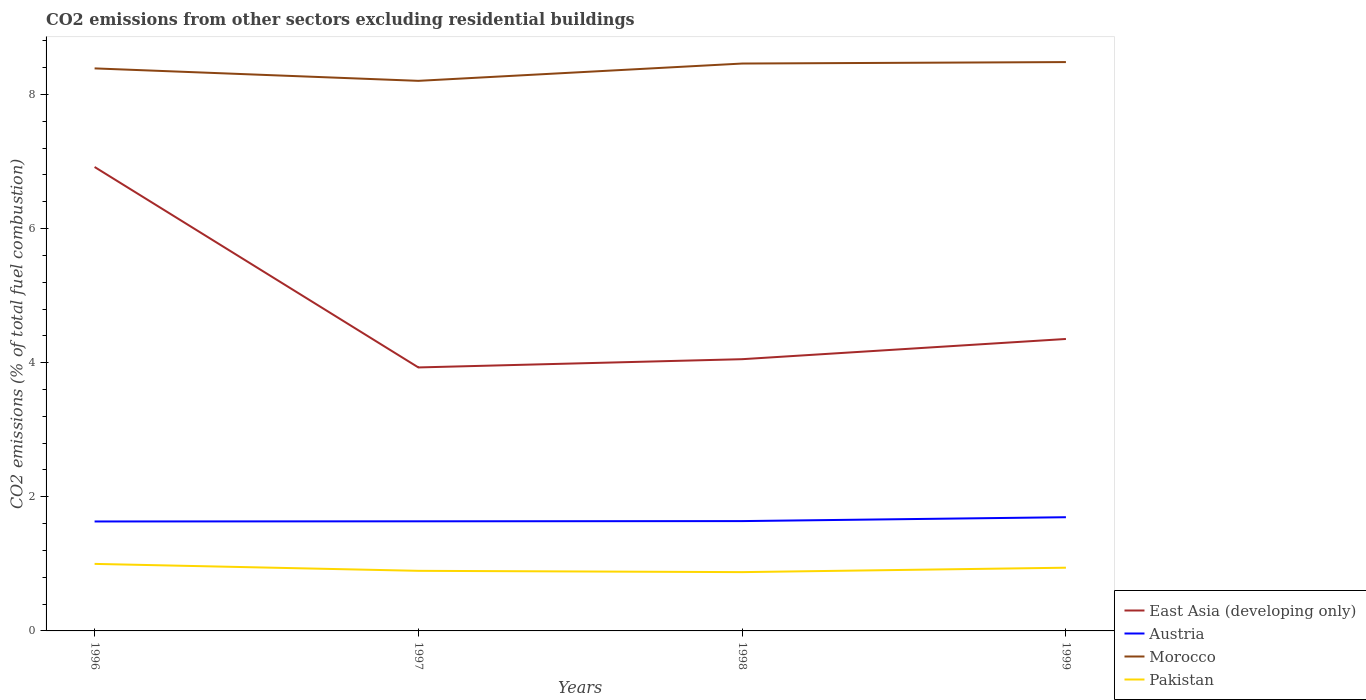How many different coloured lines are there?
Provide a short and direct response. 4. Does the line corresponding to Morocco intersect with the line corresponding to Austria?
Give a very brief answer. No. Is the number of lines equal to the number of legend labels?
Make the answer very short. Yes. Across all years, what is the maximum total CO2 emitted in Pakistan?
Provide a short and direct response. 0.88. What is the total total CO2 emitted in Pakistan in the graph?
Ensure brevity in your answer.  0.1. What is the difference between the highest and the second highest total CO2 emitted in East Asia (developing only)?
Provide a succinct answer. 2.99. What is the difference between the highest and the lowest total CO2 emitted in East Asia (developing only)?
Your response must be concise. 1. Is the total CO2 emitted in Morocco strictly greater than the total CO2 emitted in Pakistan over the years?
Keep it short and to the point. No. How many years are there in the graph?
Give a very brief answer. 4. Does the graph contain any zero values?
Your answer should be compact. No. Where does the legend appear in the graph?
Your answer should be compact. Bottom right. How are the legend labels stacked?
Give a very brief answer. Vertical. What is the title of the graph?
Keep it short and to the point. CO2 emissions from other sectors excluding residential buildings. What is the label or title of the X-axis?
Ensure brevity in your answer.  Years. What is the label or title of the Y-axis?
Provide a succinct answer. CO2 emissions (% of total fuel combustion). What is the CO2 emissions (% of total fuel combustion) of East Asia (developing only) in 1996?
Provide a succinct answer. 6.92. What is the CO2 emissions (% of total fuel combustion) of Austria in 1996?
Provide a short and direct response. 1.63. What is the CO2 emissions (% of total fuel combustion) in Morocco in 1996?
Offer a very short reply. 8.39. What is the CO2 emissions (% of total fuel combustion) of Pakistan in 1996?
Ensure brevity in your answer.  1. What is the CO2 emissions (% of total fuel combustion) in East Asia (developing only) in 1997?
Keep it short and to the point. 3.93. What is the CO2 emissions (% of total fuel combustion) in Austria in 1997?
Ensure brevity in your answer.  1.63. What is the CO2 emissions (% of total fuel combustion) in Morocco in 1997?
Make the answer very short. 8.2. What is the CO2 emissions (% of total fuel combustion) in Pakistan in 1997?
Offer a terse response. 0.9. What is the CO2 emissions (% of total fuel combustion) in East Asia (developing only) in 1998?
Give a very brief answer. 4.05. What is the CO2 emissions (% of total fuel combustion) in Austria in 1998?
Your answer should be very brief. 1.64. What is the CO2 emissions (% of total fuel combustion) of Morocco in 1998?
Provide a short and direct response. 8.46. What is the CO2 emissions (% of total fuel combustion) in Pakistan in 1998?
Your response must be concise. 0.88. What is the CO2 emissions (% of total fuel combustion) of East Asia (developing only) in 1999?
Offer a terse response. 4.35. What is the CO2 emissions (% of total fuel combustion) of Austria in 1999?
Provide a short and direct response. 1.7. What is the CO2 emissions (% of total fuel combustion) of Morocco in 1999?
Your answer should be very brief. 8.48. What is the CO2 emissions (% of total fuel combustion) in Pakistan in 1999?
Your answer should be compact. 0.94. Across all years, what is the maximum CO2 emissions (% of total fuel combustion) of East Asia (developing only)?
Your answer should be compact. 6.92. Across all years, what is the maximum CO2 emissions (% of total fuel combustion) of Austria?
Provide a succinct answer. 1.7. Across all years, what is the maximum CO2 emissions (% of total fuel combustion) in Morocco?
Keep it short and to the point. 8.48. Across all years, what is the maximum CO2 emissions (% of total fuel combustion) in Pakistan?
Ensure brevity in your answer.  1. Across all years, what is the minimum CO2 emissions (% of total fuel combustion) in East Asia (developing only)?
Keep it short and to the point. 3.93. Across all years, what is the minimum CO2 emissions (% of total fuel combustion) in Austria?
Offer a very short reply. 1.63. Across all years, what is the minimum CO2 emissions (% of total fuel combustion) in Morocco?
Offer a very short reply. 8.2. Across all years, what is the minimum CO2 emissions (% of total fuel combustion) in Pakistan?
Your response must be concise. 0.88. What is the total CO2 emissions (% of total fuel combustion) of East Asia (developing only) in the graph?
Make the answer very short. 19.25. What is the total CO2 emissions (% of total fuel combustion) of Austria in the graph?
Offer a terse response. 6.6. What is the total CO2 emissions (% of total fuel combustion) of Morocco in the graph?
Keep it short and to the point. 33.54. What is the total CO2 emissions (% of total fuel combustion) of Pakistan in the graph?
Offer a terse response. 3.71. What is the difference between the CO2 emissions (% of total fuel combustion) in East Asia (developing only) in 1996 and that in 1997?
Offer a terse response. 2.99. What is the difference between the CO2 emissions (% of total fuel combustion) of Austria in 1996 and that in 1997?
Offer a very short reply. -0. What is the difference between the CO2 emissions (% of total fuel combustion) in Morocco in 1996 and that in 1997?
Keep it short and to the point. 0.19. What is the difference between the CO2 emissions (% of total fuel combustion) in Pakistan in 1996 and that in 1997?
Make the answer very short. 0.1. What is the difference between the CO2 emissions (% of total fuel combustion) in East Asia (developing only) in 1996 and that in 1998?
Offer a terse response. 2.87. What is the difference between the CO2 emissions (% of total fuel combustion) of Austria in 1996 and that in 1998?
Provide a succinct answer. -0.01. What is the difference between the CO2 emissions (% of total fuel combustion) of Morocco in 1996 and that in 1998?
Offer a terse response. -0.07. What is the difference between the CO2 emissions (% of total fuel combustion) of Pakistan in 1996 and that in 1998?
Offer a very short reply. 0.12. What is the difference between the CO2 emissions (% of total fuel combustion) of East Asia (developing only) in 1996 and that in 1999?
Your answer should be compact. 2.56. What is the difference between the CO2 emissions (% of total fuel combustion) in Austria in 1996 and that in 1999?
Your response must be concise. -0.06. What is the difference between the CO2 emissions (% of total fuel combustion) in Morocco in 1996 and that in 1999?
Ensure brevity in your answer.  -0.09. What is the difference between the CO2 emissions (% of total fuel combustion) in Pakistan in 1996 and that in 1999?
Make the answer very short. 0.06. What is the difference between the CO2 emissions (% of total fuel combustion) of East Asia (developing only) in 1997 and that in 1998?
Make the answer very short. -0.12. What is the difference between the CO2 emissions (% of total fuel combustion) in Austria in 1997 and that in 1998?
Your response must be concise. -0. What is the difference between the CO2 emissions (% of total fuel combustion) in Morocco in 1997 and that in 1998?
Offer a very short reply. -0.26. What is the difference between the CO2 emissions (% of total fuel combustion) in Pakistan in 1997 and that in 1998?
Your answer should be compact. 0.02. What is the difference between the CO2 emissions (% of total fuel combustion) of East Asia (developing only) in 1997 and that in 1999?
Ensure brevity in your answer.  -0.42. What is the difference between the CO2 emissions (% of total fuel combustion) in Austria in 1997 and that in 1999?
Your answer should be compact. -0.06. What is the difference between the CO2 emissions (% of total fuel combustion) in Morocco in 1997 and that in 1999?
Make the answer very short. -0.28. What is the difference between the CO2 emissions (% of total fuel combustion) of Pakistan in 1997 and that in 1999?
Provide a short and direct response. -0.05. What is the difference between the CO2 emissions (% of total fuel combustion) of East Asia (developing only) in 1998 and that in 1999?
Provide a short and direct response. -0.3. What is the difference between the CO2 emissions (% of total fuel combustion) in Austria in 1998 and that in 1999?
Your answer should be compact. -0.06. What is the difference between the CO2 emissions (% of total fuel combustion) in Morocco in 1998 and that in 1999?
Provide a succinct answer. -0.02. What is the difference between the CO2 emissions (% of total fuel combustion) of Pakistan in 1998 and that in 1999?
Make the answer very short. -0.07. What is the difference between the CO2 emissions (% of total fuel combustion) in East Asia (developing only) in 1996 and the CO2 emissions (% of total fuel combustion) in Austria in 1997?
Your answer should be compact. 5.28. What is the difference between the CO2 emissions (% of total fuel combustion) of East Asia (developing only) in 1996 and the CO2 emissions (% of total fuel combustion) of Morocco in 1997?
Your answer should be very brief. -1.28. What is the difference between the CO2 emissions (% of total fuel combustion) of East Asia (developing only) in 1996 and the CO2 emissions (% of total fuel combustion) of Pakistan in 1997?
Your response must be concise. 6.02. What is the difference between the CO2 emissions (% of total fuel combustion) of Austria in 1996 and the CO2 emissions (% of total fuel combustion) of Morocco in 1997?
Offer a terse response. -6.57. What is the difference between the CO2 emissions (% of total fuel combustion) in Austria in 1996 and the CO2 emissions (% of total fuel combustion) in Pakistan in 1997?
Your answer should be compact. 0.74. What is the difference between the CO2 emissions (% of total fuel combustion) of Morocco in 1996 and the CO2 emissions (% of total fuel combustion) of Pakistan in 1997?
Your answer should be compact. 7.49. What is the difference between the CO2 emissions (% of total fuel combustion) of East Asia (developing only) in 1996 and the CO2 emissions (% of total fuel combustion) of Austria in 1998?
Give a very brief answer. 5.28. What is the difference between the CO2 emissions (% of total fuel combustion) in East Asia (developing only) in 1996 and the CO2 emissions (% of total fuel combustion) in Morocco in 1998?
Ensure brevity in your answer.  -1.54. What is the difference between the CO2 emissions (% of total fuel combustion) in East Asia (developing only) in 1996 and the CO2 emissions (% of total fuel combustion) in Pakistan in 1998?
Give a very brief answer. 6.04. What is the difference between the CO2 emissions (% of total fuel combustion) of Austria in 1996 and the CO2 emissions (% of total fuel combustion) of Morocco in 1998?
Your answer should be very brief. -6.83. What is the difference between the CO2 emissions (% of total fuel combustion) in Austria in 1996 and the CO2 emissions (% of total fuel combustion) in Pakistan in 1998?
Make the answer very short. 0.76. What is the difference between the CO2 emissions (% of total fuel combustion) in Morocco in 1996 and the CO2 emissions (% of total fuel combustion) in Pakistan in 1998?
Ensure brevity in your answer.  7.51. What is the difference between the CO2 emissions (% of total fuel combustion) of East Asia (developing only) in 1996 and the CO2 emissions (% of total fuel combustion) of Austria in 1999?
Your answer should be compact. 5.22. What is the difference between the CO2 emissions (% of total fuel combustion) in East Asia (developing only) in 1996 and the CO2 emissions (% of total fuel combustion) in Morocco in 1999?
Make the answer very short. -1.56. What is the difference between the CO2 emissions (% of total fuel combustion) in East Asia (developing only) in 1996 and the CO2 emissions (% of total fuel combustion) in Pakistan in 1999?
Make the answer very short. 5.98. What is the difference between the CO2 emissions (% of total fuel combustion) in Austria in 1996 and the CO2 emissions (% of total fuel combustion) in Morocco in 1999?
Keep it short and to the point. -6.85. What is the difference between the CO2 emissions (% of total fuel combustion) of Austria in 1996 and the CO2 emissions (% of total fuel combustion) of Pakistan in 1999?
Provide a short and direct response. 0.69. What is the difference between the CO2 emissions (% of total fuel combustion) of Morocco in 1996 and the CO2 emissions (% of total fuel combustion) of Pakistan in 1999?
Offer a very short reply. 7.45. What is the difference between the CO2 emissions (% of total fuel combustion) in East Asia (developing only) in 1997 and the CO2 emissions (% of total fuel combustion) in Austria in 1998?
Provide a short and direct response. 2.29. What is the difference between the CO2 emissions (% of total fuel combustion) of East Asia (developing only) in 1997 and the CO2 emissions (% of total fuel combustion) of Morocco in 1998?
Keep it short and to the point. -4.53. What is the difference between the CO2 emissions (% of total fuel combustion) in East Asia (developing only) in 1997 and the CO2 emissions (% of total fuel combustion) in Pakistan in 1998?
Your answer should be compact. 3.05. What is the difference between the CO2 emissions (% of total fuel combustion) of Austria in 1997 and the CO2 emissions (% of total fuel combustion) of Morocco in 1998?
Provide a short and direct response. -6.83. What is the difference between the CO2 emissions (% of total fuel combustion) in Austria in 1997 and the CO2 emissions (% of total fuel combustion) in Pakistan in 1998?
Your answer should be compact. 0.76. What is the difference between the CO2 emissions (% of total fuel combustion) of Morocco in 1997 and the CO2 emissions (% of total fuel combustion) of Pakistan in 1998?
Your answer should be compact. 7.33. What is the difference between the CO2 emissions (% of total fuel combustion) of East Asia (developing only) in 1997 and the CO2 emissions (% of total fuel combustion) of Austria in 1999?
Provide a succinct answer. 2.23. What is the difference between the CO2 emissions (% of total fuel combustion) in East Asia (developing only) in 1997 and the CO2 emissions (% of total fuel combustion) in Morocco in 1999?
Offer a very short reply. -4.55. What is the difference between the CO2 emissions (% of total fuel combustion) in East Asia (developing only) in 1997 and the CO2 emissions (% of total fuel combustion) in Pakistan in 1999?
Provide a short and direct response. 2.99. What is the difference between the CO2 emissions (% of total fuel combustion) of Austria in 1997 and the CO2 emissions (% of total fuel combustion) of Morocco in 1999?
Provide a succinct answer. -6.85. What is the difference between the CO2 emissions (% of total fuel combustion) of Austria in 1997 and the CO2 emissions (% of total fuel combustion) of Pakistan in 1999?
Give a very brief answer. 0.69. What is the difference between the CO2 emissions (% of total fuel combustion) in Morocco in 1997 and the CO2 emissions (% of total fuel combustion) in Pakistan in 1999?
Ensure brevity in your answer.  7.26. What is the difference between the CO2 emissions (% of total fuel combustion) in East Asia (developing only) in 1998 and the CO2 emissions (% of total fuel combustion) in Austria in 1999?
Provide a short and direct response. 2.36. What is the difference between the CO2 emissions (% of total fuel combustion) of East Asia (developing only) in 1998 and the CO2 emissions (% of total fuel combustion) of Morocco in 1999?
Provide a succinct answer. -4.43. What is the difference between the CO2 emissions (% of total fuel combustion) of East Asia (developing only) in 1998 and the CO2 emissions (% of total fuel combustion) of Pakistan in 1999?
Your answer should be very brief. 3.11. What is the difference between the CO2 emissions (% of total fuel combustion) in Austria in 1998 and the CO2 emissions (% of total fuel combustion) in Morocco in 1999?
Offer a terse response. -6.84. What is the difference between the CO2 emissions (% of total fuel combustion) in Austria in 1998 and the CO2 emissions (% of total fuel combustion) in Pakistan in 1999?
Ensure brevity in your answer.  0.7. What is the difference between the CO2 emissions (% of total fuel combustion) of Morocco in 1998 and the CO2 emissions (% of total fuel combustion) of Pakistan in 1999?
Give a very brief answer. 7.52. What is the average CO2 emissions (% of total fuel combustion) in East Asia (developing only) per year?
Ensure brevity in your answer.  4.81. What is the average CO2 emissions (% of total fuel combustion) of Austria per year?
Provide a succinct answer. 1.65. What is the average CO2 emissions (% of total fuel combustion) in Morocco per year?
Your answer should be compact. 8.38. What is the average CO2 emissions (% of total fuel combustion) in Pakistan per year?
Offer a terse response. 0.93. In the year 1996, what is the difference between the CO2 emissions (% of total fuel combustion) of East Asia (developing only) and CO2 emissions (% of total fuel combustion) of Austria?
Your answer should be very brief. 5.29. In the year 1996, what is the difference between the CO2 emissions (% of total fuel combustion) in East Asia (developing only) and CO2 emissions (% of total fuel combustion) in Morocco?
Keep it short and to the point. -1.47. In the year 1996, what is the difference between the CO2 emissions (% of total fuel combustion) in East Asia (developing only) and CO2 emissions (% of total fuel combustion) in Pakistan?
Offer a very short reply. 5.92. In the year 1996, what is the difference between the CO2 emissions (% of total fuel combustion) in Austria and CO2 emissions (% of total fuel combustion) in Morocco?
Offer a terse response. -6.76. In the year 1996, what is the difference between the CO2 emissions (% of total fuel combustion) in Austria and CO2 emissions (% of total fuel combustion) in Pakistan?
Give a very brief answer. 0.63. In the year 1996, what is the difference between the CO2 emissions (% of total fuel combustion) of Morocco and CO2 emissions (% of total fuel combustion) of Pakistan?
Offer a very short reply. 7.39. In the year 1997, what is the difference between the CO2 emissions (% of total fuel combustion) in East Asia (developing only) and CO2 emissions (% of total fuel combustion) in Austria?
Ensure brevity in your answer.  2.29. In the year 1997, what is the difference between the CO2 emissions (% of total fuel combustion) of East Asia (developing only) and CO2 emissions (% of total fuel combustion) of Morocco?
Give a very brief answer. -4.27. In the year 1997, what is the difference between the CO2 emissions (% of total fuel combustion) of East Asia (developing only) and CO2 emissions (% of total fuel combustion) of Pakistan?
Provide a succinct answer. 3.03. In the year 1997, what is the difference between the CO2 emissions (% of total fuel combustion) of Austria and CO2 emissions (% of total fuel combustion) of Morocco?
Give a very brief answer. -6.57. In the year 1997, what is the difference between the CO2 emissions (% of total fuel combustion) in Austria and CO2 emissions (% of total fuel combustion) in Pakistan?
Provide a succinct answer. 0.74. In the year 1997, what is the difference between the CO2 emissions (% of total fuel combustion) in Morocco and CO2 emissions (% of total fuel combustion) in Pakistan?
Your answer should be compact. 7.31. In the year 1998, what is the difference between the CO2 emissions (% of total fuel combustion) in East Asia (developing only) and CO2 emissions (% of total fuel combustion) in Austria?
Make the answer very short. 2.41. In the year 1998, what is the difference between the CO2 emissions (% of total fuel combustion) in East Asia (developing only) and CO2 emissions (% of total fuel combustion) in Morocco?
Make the answer very short. -4.41. In the year 1998, what is the difference between the CO2 emissions (% of total fuel combustion) in East Asia (developing only) and CO2 emissions (% of total fuel combustion) in Pakistan?
Offer a very short reply. 3.18. In the year 1998, what is the difference between the CO2 emissions (% of total fuel combustion) in Austria and CO2 emissions (% of total fuel combustion) in Morocco?
Provide a succinct answer. -6.82. In the year 1998, what is the difference between the CO2 emissions (% of total fuel combustion) in Austria and CO2 emissions (% of total fuel combustion) in Pakistan?
Ensure brevity in your answer.  0.76. In the year 1998, what is the difference between the CO2 emissions (% of total fuel combustion) of Morocco and CO2 emissions (% of total fuel combustion) of Pakistan?
Make the answer very short. 7.58. In the year 1999, what is the difference between the CO2 emissions (% of total fuel combustion) of East Asia (developing only) and CO2 emissions (% of total fuel combustion) of Austria?
Keep it short and to the point. 2.66. In the year 1999, what is the difference between the CO2 emissions (% of total fuel combustion) of East Asia (developing only) and CO2 emissions (% of total fuel combustion) of Morocco?
Your response must be concise. -4.13. In the year 1999, what is the difference between the CO2 emissions (% of total fuel combustion) of East Asia (developing only) and CO2 emissions (% of total fuel combustion) of Pakistan?
Your answer should be compact. 3.41. In the year 1999, what is the difference between the CO2 emissions (% of total fuel combustion) of Austria and CO2 emissions (% of total fuel combustion) of Morocco?
Your response must be concise. -6.79. In the year 1999, what is the difference between the CO2 emissions (% of total fuel combustion) in Austria and CO2 emissions (% of total fuel combustion) in Pakistan?
Provide a short and direct response. 0.75. In the year 1999, what is the difference between the CO2 emissions (% of total fuel combustion) in Morocco and CO2 emissions (% of total fuel combustion) in Pakistan?
Make the answer very short. 7.54. What is the ratio of the CO2 emissions (% of total fuel combustion) in East Asia (developing only) in 1996 to that in 1997?
Your response must be concise. 1.76. What is the ratio of the CO2 emissions (% of total fuel combustion) in Morocco in 1996 to that in 1997?
Offer a terse response. 1.02. What is the ratio of the CO2 emissions (% of total fuel combustion) of Pakistan in 1996 to that in 1997?
Keep it short and to the point. 1.12. What is the ratio of the CO2 emissions (% of total fuel combustion) of East Asia (developing only) in 1996 to that in 1998?
Offer a very short reply. 1.71. What is the ratio of the CO2 emissions (% of total fuel combustion) of Austria in 1996 to that in 1998?
Your answer should be very brief. 1. What is the ratio of the CO2 emissions (% of total fuel combustion) of Morocco in 1996 to that in 1998?
Offer a terse response. 0.99. What is the ratio of the CO2 emissions (% of total fuel combustion) of Pakistan in 1996 to that in 1998?
Make the answer very short. 1.14. What is the ratio of the CO2 emissions (% of total fuel combustion) of East Asia (developing only) in 1996 to that in 1999?
Provide a short and direct response. 1.59. What is the ratio of the CO2 emissions (% of total fuel combustion) of Austria in 1996 to that in 1999?
Make the answer very short. 0.96. What is the ratio of the CO2 emissions (% of total fuel combustion) of Morocco in 1996 to that in 1999?
Keep it short and to the point. 0.99. What is the ratio of the CO2 emissions (% of total fuel combustion) in Pakistan in 1996 to that in 1999?
Offer a terse response. 1.06. What is the ratio of the CO2 emissions (% of total fuel combustion) in East Asia (developing only) in 1997 to that in 1998?
Give a very brief answer. 0.97. What is the ratio of the CO2 emissions (% of total fuel combustion) of Austria in 1997 to that in 1998?
Your response must be concise. 1. What is the ratio of the CO2 emissions (% of total fuel combustion) in Morocco in 1997 to that in 1998?
Provide a succinct answer. 0.97. What is the ratio of the CO2 emissions (% of total fuel combustion) in Pakistan in 1997 to that in 1998?
Make the answer very short. 1.02. What is the ratio of the CO2 emissions (% of total fuel combustion) in East Asia (developing only) in 1997 to that in 1999?
Ensure brevity in your answer.  0.9. What is the ratio of the CO2 emissions (% of total fuel combustion) of Austria in 1997 to that in 1999?
Keep it short and to the point. 0.96. What is the ratio of the CO2 emissions (% of total fuel combustion) of Pakistan in 1997 to that in 1999?
Give a very brief answer. 0.95. What is the ratio of the CO2 emissions (% of total fuel combustion) in East Asia (developing only) in 1998 to that in 1999?
Your answer should be compact. 0.93. What is the ratio of the CO2 emissions (% of total fuel combustion) of Austria in 1998 to that in 1999?
Keep it short and to the point. 0.97. What is the ratio of the CO2 emissions (% of total fuel combustion) in Morocco in 1998 to that in 1999?
Make the answer very short. 1. What is the ratio of the CO2 emissions (% of total fuel combustion) in Pakistan in 1998 to that in 1999?
Your answer should be compact. 0.93. What is the difference between the highest and the second highest CO2 emissions (% of total fuel combustion) of East Asia (developing only)?
Keep it short and to the point. 2.56. What is the difference between the highest and the second highest CO2 emissions (% of total fuel combustion) of Austria?
Your answer should be very brief. 0.06. What is the difference between the highest and the second highest CO2 emissions (% of total fuel combustion) in Morocco?
Your response must be concise. 0.02. What is the difference between the highest and the second highest CO2 emissions (% of total fuel combustion) in Pakistan?
Your response must be concise. 0.06. What is the difference between the highest and the lowest CO2 emissions (% of total fuel combustion) in East Asia (developing only)?
Ensure brevity in your answer.  2.99. What is the difference between the highest and the lowest CO2 emissions (% of total fuel combustion) of Austria?
Offer a very short reply. 0.06. What is the difference between the highest and the lowest CO2 emissions (% of total fuel combustion) of Morocco?
Offer a very short reply. 0.28. What is the difference between the highest and the lowest CO2 emissions (% of total fuel combustion) in Pakistan?
Provide a short and direct response. 0.12. 